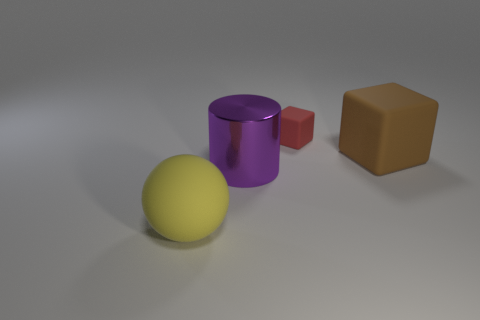Add 3 brown cylinders. How many objects exist? 7 Subtract all balls. How many objects are left? 3 Add 2 tiny cyan matte cylinders. How many tiny cyan matte cylinders exist? 2 Subtract 0 blue cylinders. How many objects are left? 4 Subtract all big cyan rubber things. Subtract all red rubber cubes. How many objects are left? 3 Add 2 large rubber objects. How many large rubber objects are left? 4 